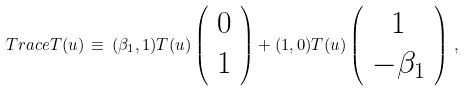<formula> <loc_0><loc_0><loc_500><loc_500>T r a c e T ( u ) \, \equiv \, ( \beta _ { 1 } , 1 ) T ( u ) \left ( \begin{array} { c } 0 \\ 1 \end{array} \right ) + ( 1 , 0 ) T ( u ) \left ( \begin{array} { c } 1 \\ - \beta _ { 1 } \end{array} \right ) \, ,</formula> 